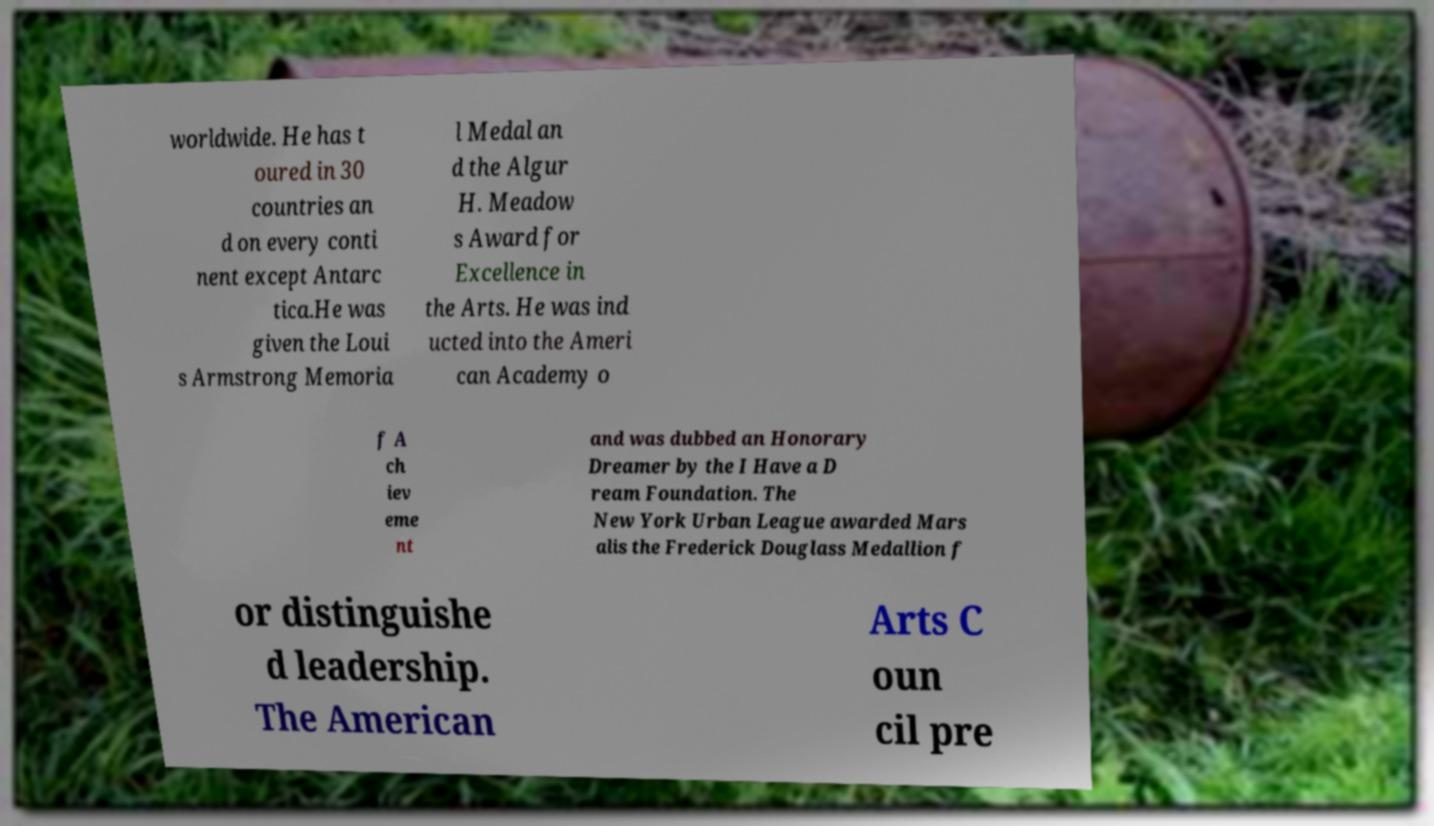There's text embedded in this image that I need extracted. Can you transcribe it verbatim? worldwide. He has t oured in 30 countries an d on every conti nent except Antarc tica.He was given the Loui s Armstrong Memoria l Medal an d the Algur H. Meadow s Award for Excellence in the Arts. He was ind ucted into the Ameri can Academy o f A ch iev eme nt and was dubbed an Honorary Dreamer by the I Have a D ream Foundation. The New York Urban League awarded Mars alis the Frederick Douglass Medallion f or distinguishe d leadership. The American Arts C oun cil pre 